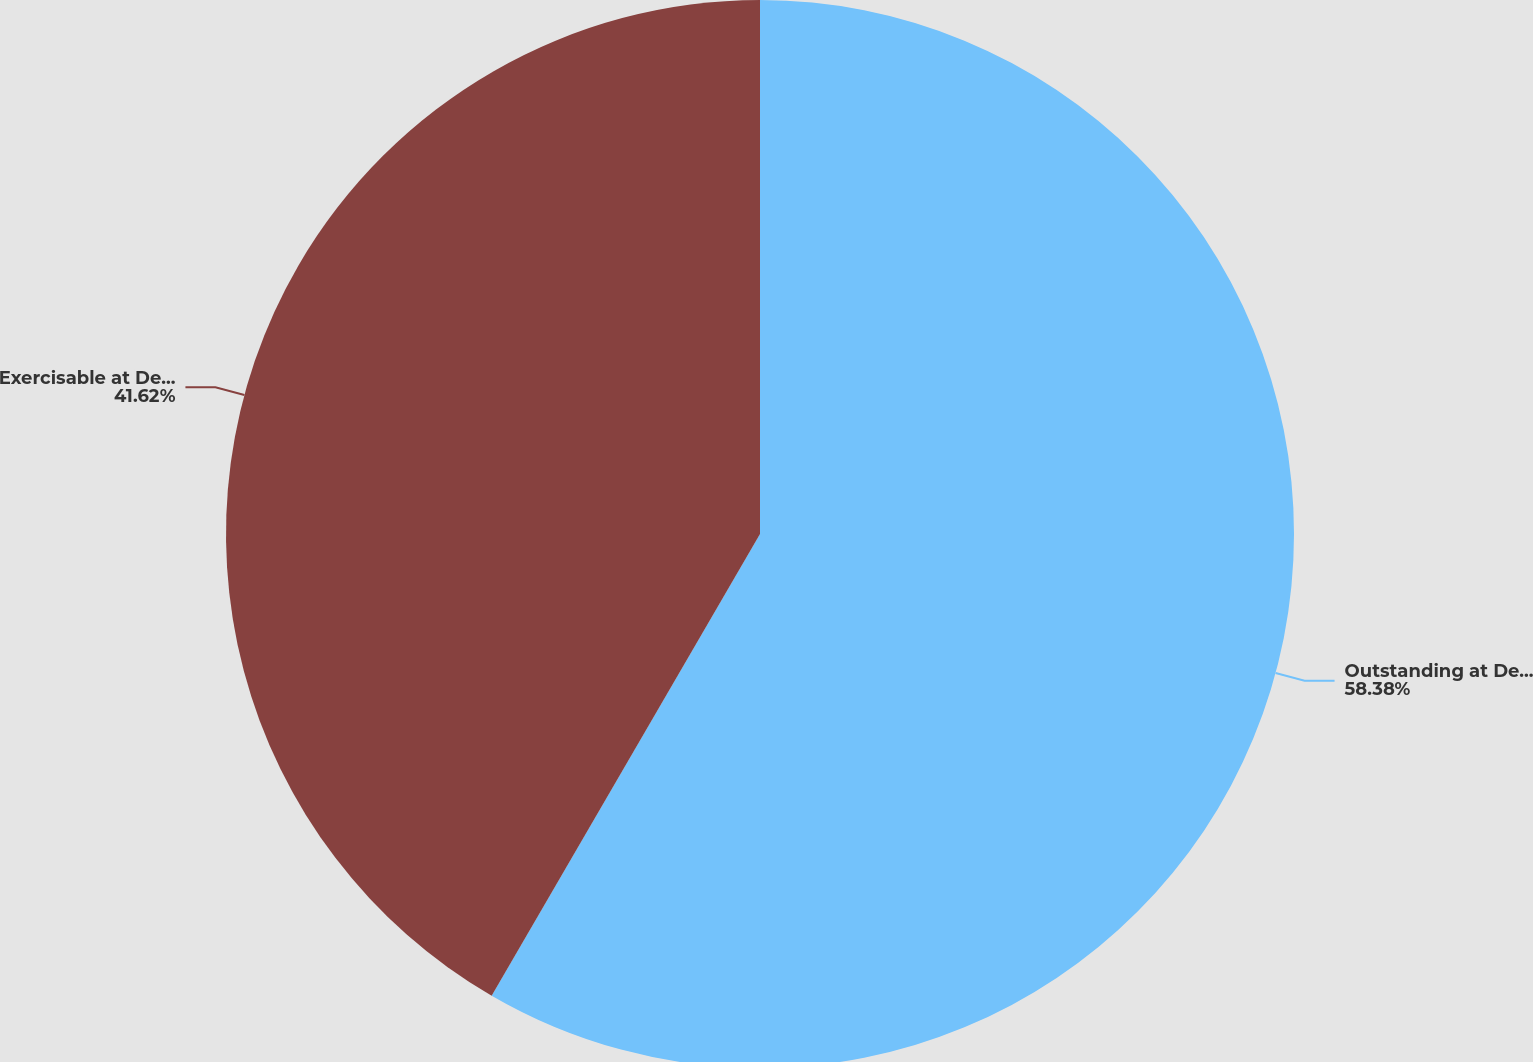<chart> <loc_0><loc_0><loc_500><loc_500><pie_chart><fcel>Outstanding at December 31<fcel>Exercisable at December 31<nl><fcel>58.38%<fcel>41.62%<nl></chart> 